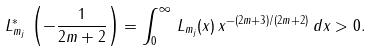Convert formula to latex. <formula><loc_0><loc_0><loc_500><loc_500>L ^ { * } _ { m _ { j } } \, \left ( - \frac { 1 } { 2 m + 2 } \right ) = \int ^ { \infty } _ { 0 } \, L _ { m _ { j } } ( x ) \, x ^ { - ( 2 m + 3 ) / ( 2 m + 2 ) } \, d x > 0 .</formula> 